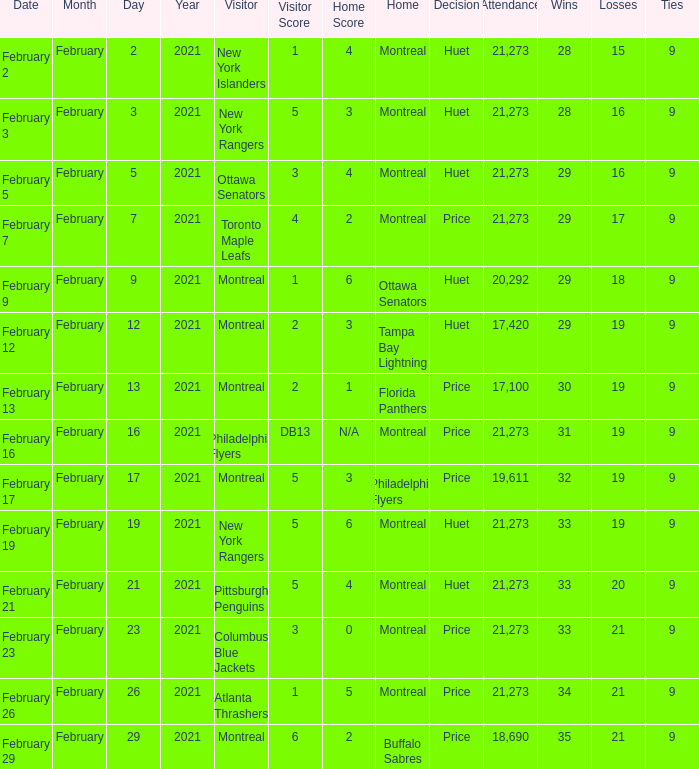What was the date of the game when the Canadiens had a record of 31–19–9? February 16. 